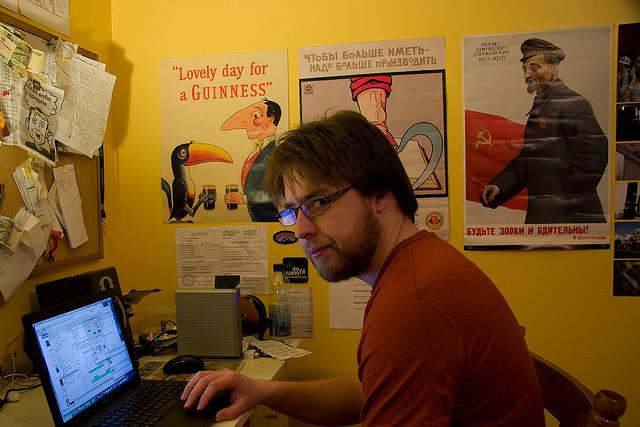What are the toucan and the man going to enjoy? Please explain your reasoning. beer. The toucan on the poster is holding a glass of guiness beer. 